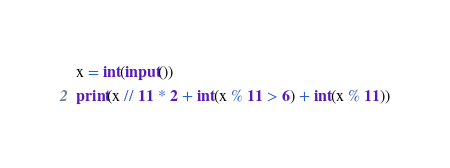Convert code to text. <code><loc_0><loc_0><loc_500><loc_500><_Python_>x = int(input())
print(x // 11 * 2 + int(x % 11 > 6) + int(x % 11))
</code> 